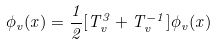Convert formula to latex. <formula><loc_0><loc_0><loc_500><loc_500>\phi _ { v } ( x ) = \frac { 1 } { 2 } [ T _ { v } ^ { 3 } + T _ { v } ^ { - 1 } ] \phi _ { v } ( x )</formula> 